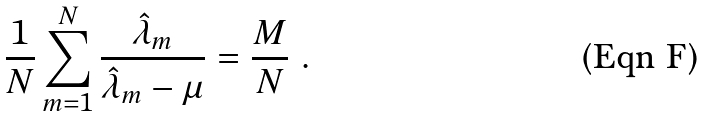<formula> <loc_0><loc_0><loc_500><loc_500>\frac { 1 } { N } \sum _ { m = 1 } ^ { N } \frac { \hat { \lambda } _ { m } } { \hat { \lambda } _ { m } - \mu } = \frac { M } { N } \ .</formula> 